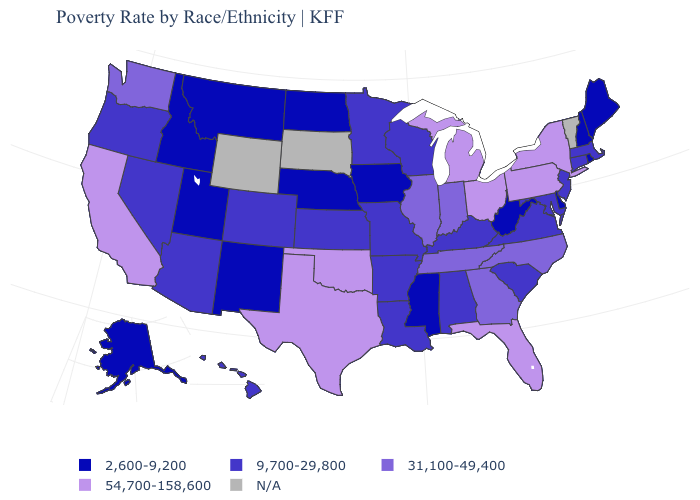What is the value of South Carolina?
Write a very short answer. 9,700-29,800. What is the value of Montana?
Concise answer only. 2,600-9,200. Which states hav the highest value in the MidWest?
Keep it brief. Michigan, Ohio. Among the states that border Maryland , which have the lowest value?
Write a very short answer. Delaware, West Virginia. Name the states that have a value in the range N/A?
Answer briefly. South Dakota, Vermont, Wyoming. What is the lowest value in the USA?
Keep it brief. 2,600-9,200. Which states have the lowest value in the South?
Short answer required. Delaware, Mississippi, West Virginia. Name the states that have a value in the range N/A?
Give a very brief answer. South Dakota, Vermont, Wyoming. What is the lowest value in states that border South Carolina?
Give a very brief answer. 31,100-49,400. Name the states that have a value in the range 9,700-29,800?
Be succinct. Alabama, Arizona, Arkansas, Colorado, Connecticut, Hawaii, Kansas, Kentucky, Louisiana, Maryland, Massachusetts, Minnesota, Missouri, Nevada, New Jersey, Oregon, South Carolina, Virginia, Wisconsin. Does the first symbol in the legend represent the smallest category?
Quick response, please. Yes. What is the value of Oklahoma?
Keep it brief. 54,700-158,600. What is the lowest value in the USA?
Be succinct. 2,600-9,200. 